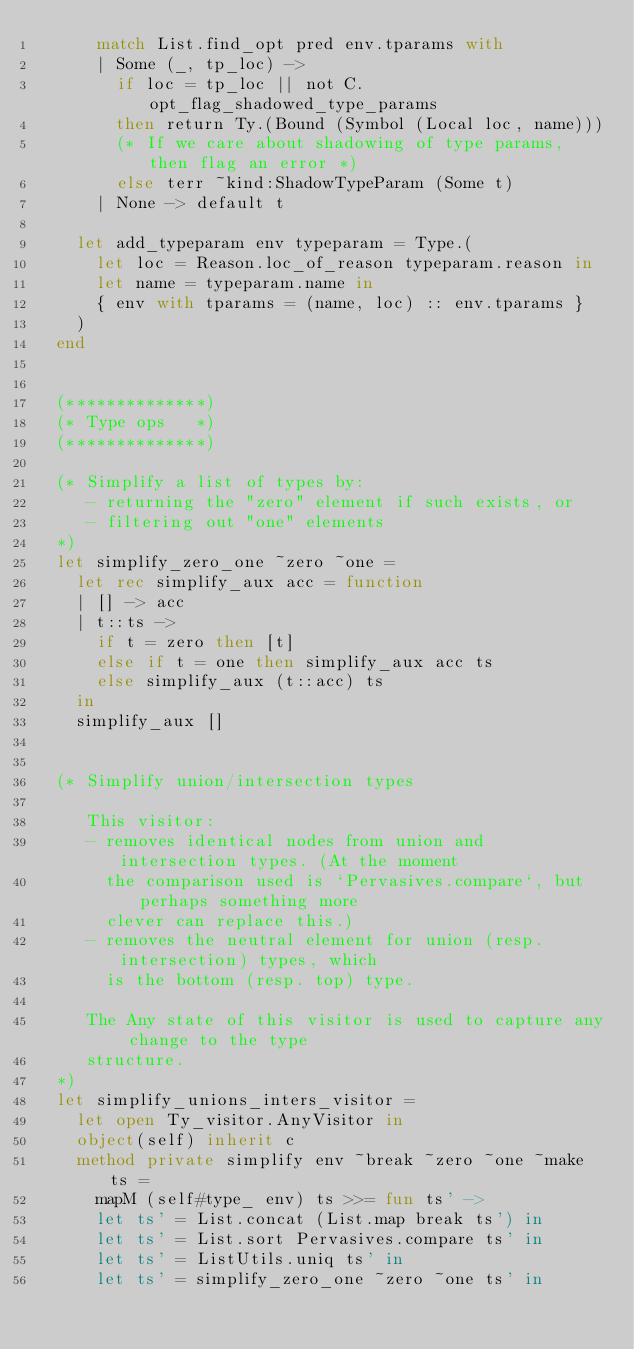<code> <loc_0><loc_0><loc_500><loc_500><_OCaml_>      match List.find_opt pred env.tparams with
      | Some (_, tp_loc) ->
        if loc = tp_loc || not C.opt_flag_shadowed_type_params
        then return Ty.(Bound (Symbol (Local loc, name)))
        (* If we care about shadowing of type params, then flag an error *)
        else terr ~kind:ShadowTypeParam (Some t)
      | None -> default t

    let add_typeparam env typeparam = Type.(
      let loc = Reason.loc_of_reason typeparam.reason in
      let name = typeparam.name in
      { env with tparams = (name, loc) :: env.tparams }
    )
  end


  (**************)
  (* Type ops   *)
  (**************)

  (* Simplify a list of types by:
     - returning the "zero" element if such exists, or
     - filtering out "one" elements
  *)
  let simplify_zero_one ~zero ~one =
    let rec simplify_aux acc = function
    | [] -> acc
    | t::ts ->
      if t = zero then [t]
      else if t = one then simplify_aux acc ts
      else simplify_aux (t::acc) ts
    in
    simplify_aux []


  (* Simplify union/intersection types

     This visitor:
     - removes identical nodes from union and intersection types. (At the moment
       the comparison used is `Pervasives.compare`, but perhaps something more
       clever can replace this.)
     - removes the neutral element for union (resp. intersection) types, which
       is the bottom (resp. top) type.

     The Any state of this visitor is used to capture any change to the type
     structure.
  *)
  let simplify_unions_inters_visitor =
    let open Ty_visitor.AnyVisitor in
    object(self) inherit c
    method private simplify env ~break ~zero ~one ~make ts =
      mapM (self#type_ env) ts >>= fun ts' ->
      let ts' = List.concat (List.map break ts') in
      let ts' = List.sort Pervasives.compare ts' in
      let ts' = ListUtils.uniq ts' in
      let ts' = simplify_zero_one ~zero ~one ts' in</code> 